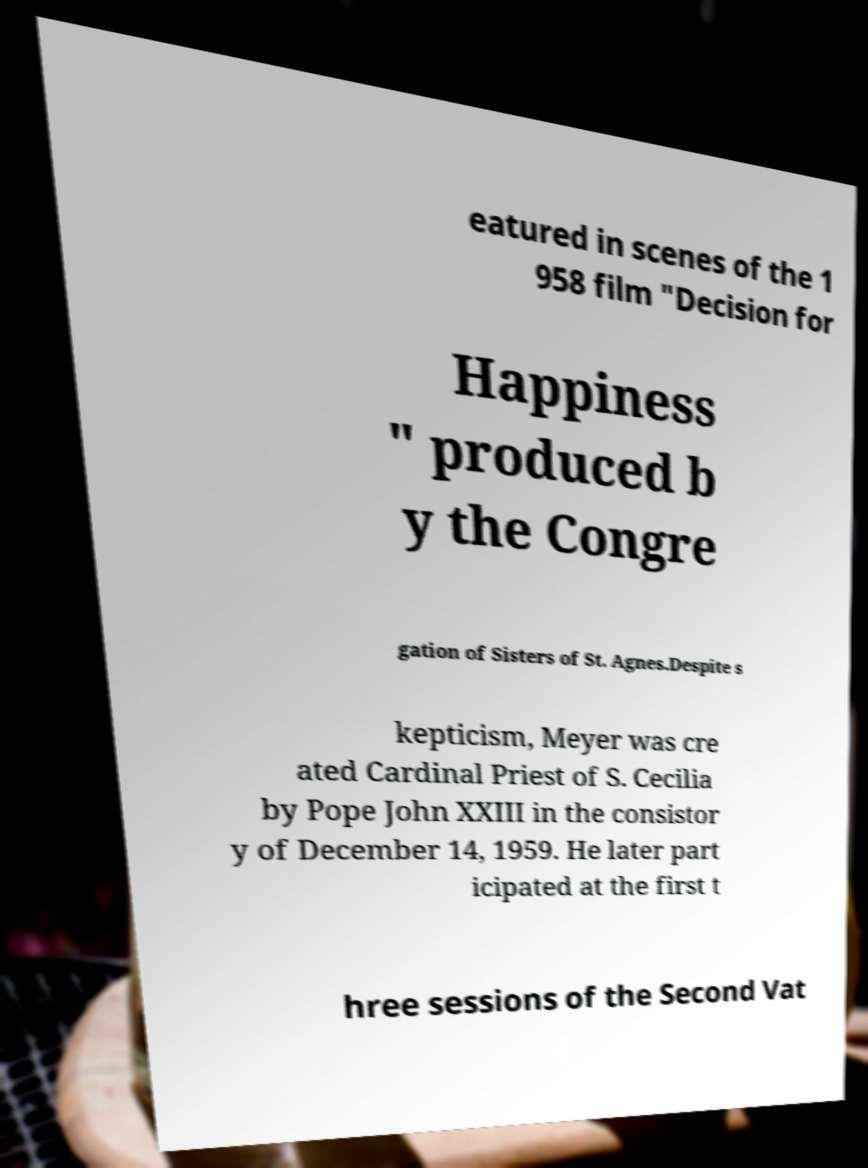For documentation purposes, I need the text within this image transcribed. Could you provide that? eatured in scenes of the 1 958 film "Decision for Happiness " produced b y the Congre gation of Sisters of St. Agnes.Despite s kepticism, Meyer was cre ated Cardinal Priest of S. Cecilia by Pope John XXIII in the consistor y of December 14, 1959. He later part icipated at the first t hree sessions of the Second Vat 